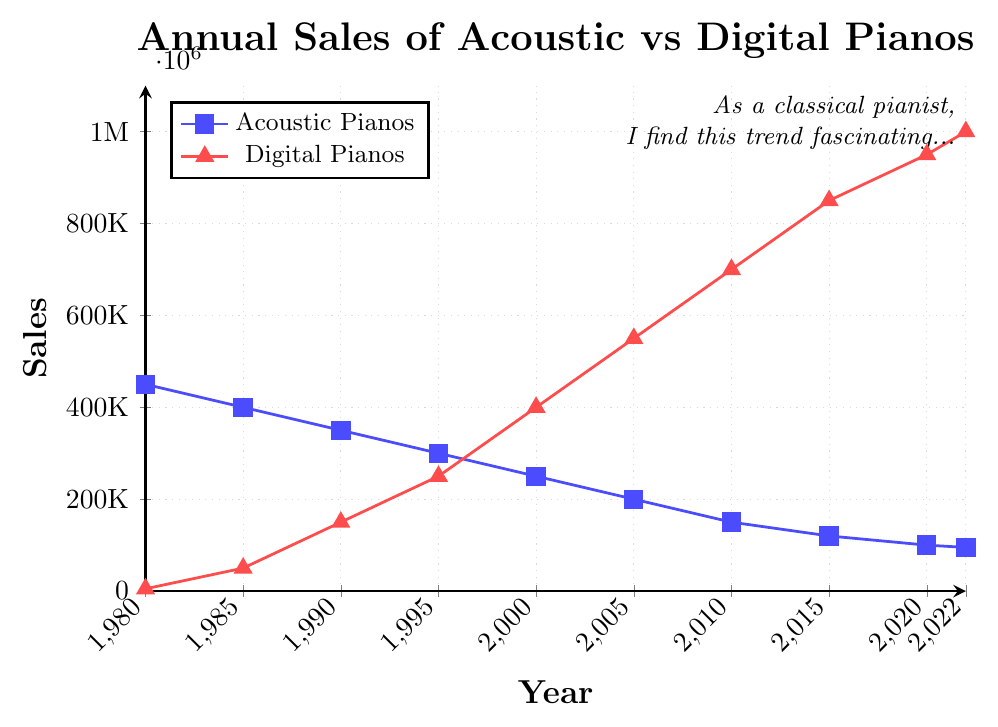How have the annual sales of acoustic pianos changed from 1980 to 2022? The sales of acoustic pianos have consistently decreased over the years. In 1980, the sales were 450,000 units, and by 2022, they had declined to 95,000 units.
Answer: They have decreased What is the difference in sales between acoustic and digital pianos in the year 2005? In 2005, the sales of acoustic pianos were 200,000 units, and the sales of digital pianos were 550,000 units. The difference is found by subtracting the smaller number from the larger: 550,000 - 200,000 = 350,000.
Answer: 350,000 When did the annual sales of digital pianos surpass those of acoustic pianos? By looking at the chart, the sales of digital pianos surpassed those of acoustic pianos around the year 2000. In 2000, digital pianos had sales of 400,000 units, whereas acoustic pianos had 250,000 units.
Answer: Around the year 2000 What is the average annual sales of digital pianos from 1980 to 2022? Sum up the annual sales of digital pianos from 1980 to 2022: (5000 + 50000 + 150000 + 250000 + 400000 + 550000 + 700000 + 850000 + 950000 + 1000000) = 5,525,000. Divide this by the number of data points (10): 5,525,000 / 10 = 552,500
Answer: 552,500 How do the sales trends of acoustic and digital pianos compare visually on the plot? The sales of acoustic pianos, represented by blue squares, show a general downward trend from 1980 to 2022. In contrast, the sales of digital pianos, represented by red triangles, show an upward trend.
Answer: Acoustic sales decrease, digital sales increase What year showed the largest increase in digital piano sales compared to the previous period? By examining the differences between consecutive years: (1985-1980) = 45,000, (1990-1985) = 100,000, (1995-1990) = 100,000, (2000-1995) = 150,000, (2005-2000) = 150,000, (2010-2005) = 150,000, (2015-2010) = 150,000, (2020-2015) = 100,000, (2022-2020) = 50,000. The largest increase is from 2000 to 2005, 150,000.
Answer: 2000 to 2005 What can you infer about the overall market trends based on the data? The sustained decline in acoustic piano sales and rise in digital piano sales suggest that the market has been shifting towards digital pianos over time. This could be due to technological advancements, changes in consumer preferences, or other factors.
Answer: Shift towards digital pianos Which year had the closest sales figures between acoustic and digital pianos? The year 1995 had the closest figures, with acoustic pianos at 300,000 and digital pianos at 250,000 units, resulting in a difference of 50,000 units.
Answer: 1995 